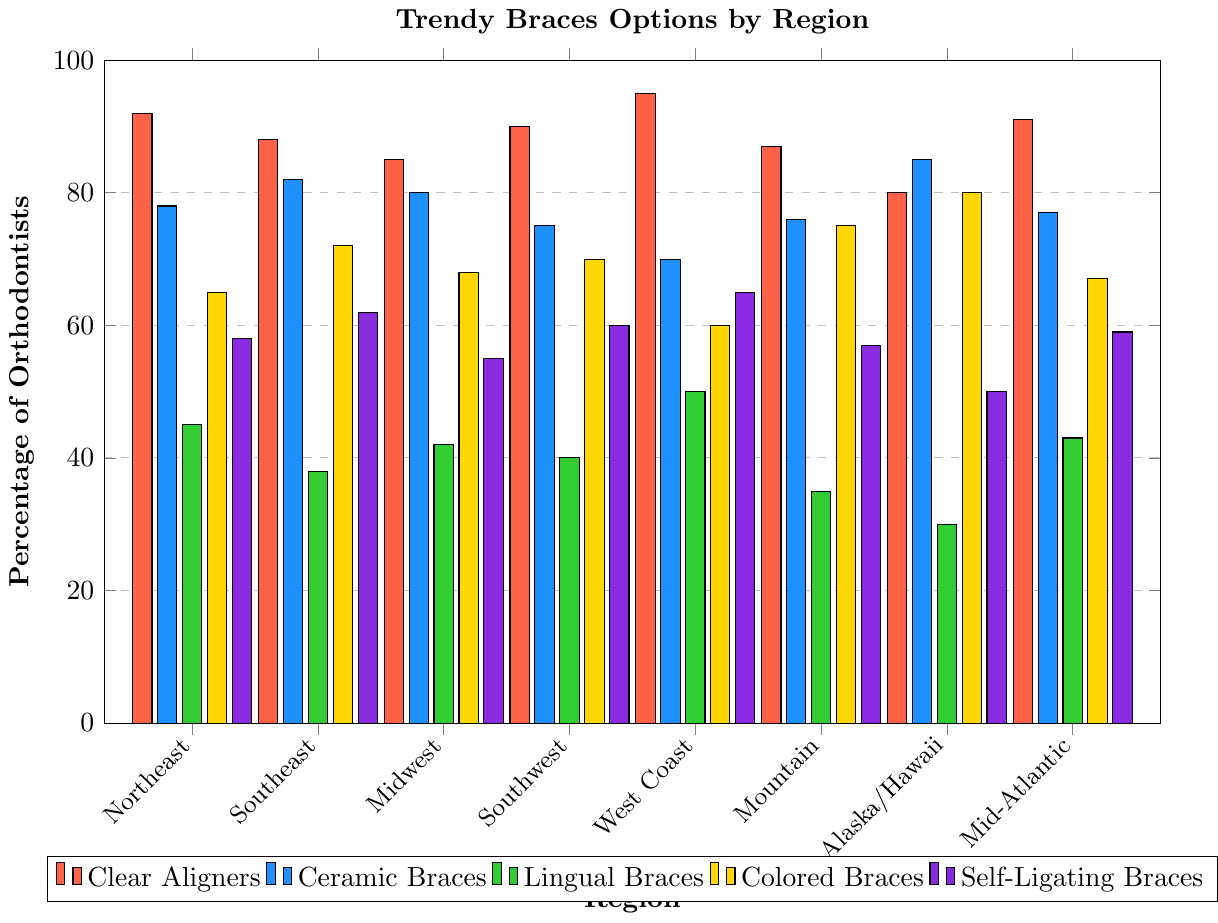Which region has the highest percentage of orthodontists offering Clear Aligners? The highest bar in the Clear Aligners category across all regions represents the West Coast.
Answer: West Coast Among Ceramic Braces, which region has the least percentage of orthodontists offering them? The smallest bar in the Ceramic Braces category is for the West Coast.
Answer: West Coast Which braces option has the highest percentage of orthodontists offering it in the Southeast region? By looking at the longest bar in the Southeast region, we see that Colored Braces have the highest percentage.
Answer: Colored Braces What is the difference in percentage between the highest and lowest regions offering Lingual Braces? The highest percentage for Lingual Braces is on the West Coast (50%) and the lowest is in Alaska/Hawaii (30%). The difference is 50 - 30 = 20%.
Answer: 20% Which region has the highest combined percentage for offering both Clear Aligners and Ceramic Braces? Add the percentages for Clear Aligners and Ceramic Braces across all regions. Alaska/Hawaii has the highest combined percentage: 80 + 85 = 165%.
Answer: Alaska/Hawaii How many regions have more than 70% of orthodontists offering Colored Braces? Count the regions where the bar for Colored Braces is above 70%. Southeast, Southwest, Mountain, and Alaska/Hawaii. So there are 4 regions.
Answer: 4 Which braces option is offered by the least percentage of orthodontists in the Midwest region? The smallest bar in the Midwest region is for Lingual Braces.
Answer: Lingual Braces What is the average percentage of orthodontists offering Self-Ligating Braces across all regions? Add the percentages for Self-Ligating Braces in all regions: (58 + 62 + 55 + 60 + 65 + 57 + 50 + 59) = 466. Then divide by the number of regions (8), so the average is 466 / 8 = 58.25%.
Answer: 58.25% Which region has the most evenly distributed percentages across all types of braces options? The bars for all options in the Mountain region are the closest in height compared to other regions.
Answer: Mountain 